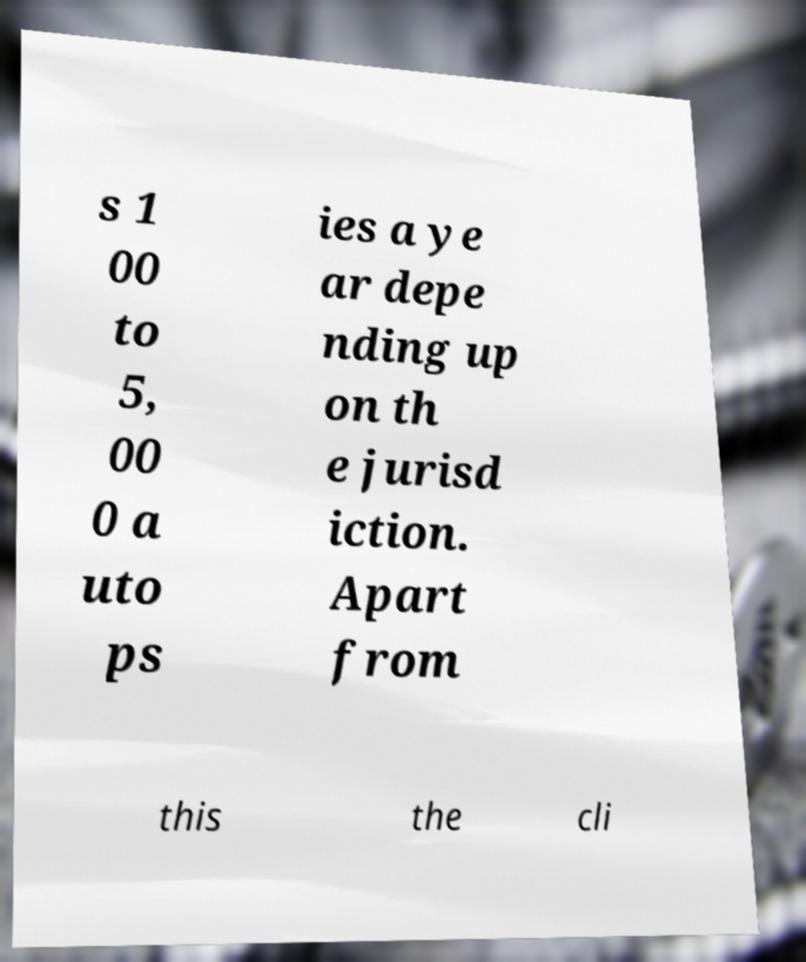Please read and relay the text visible in this image. What does it say? s 1 00 to 5, 00 0 a uto ps ies a ye ar depe nding up on th e jurisd iction. Apart from this the cli 